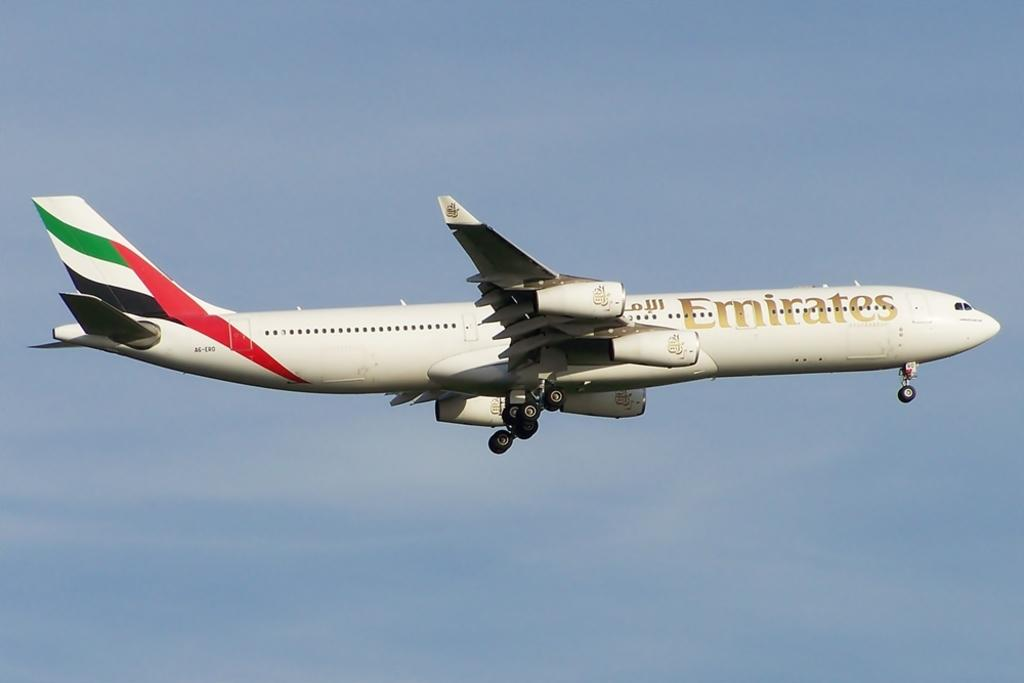Provide a one-sentence caption for the provided image. An Emirates plane is flying through a blue sky. 